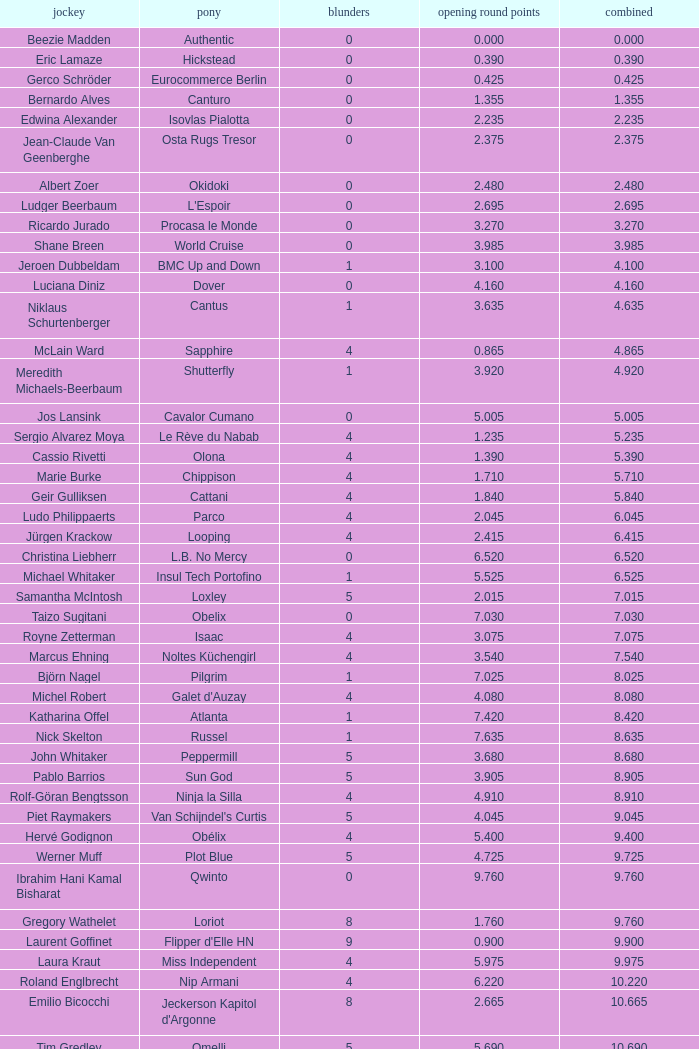Tell me the most total for horse of carlson 29.545. 